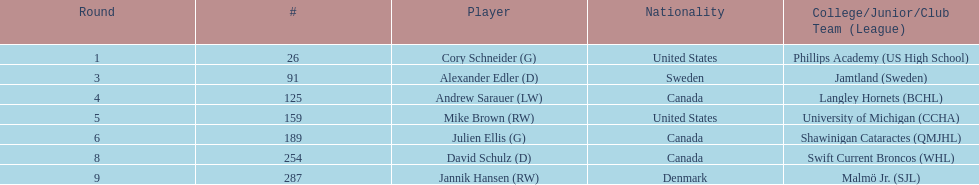Which player has canadian nationality and attended langley hornets? Andrew Sarauer (LW). 